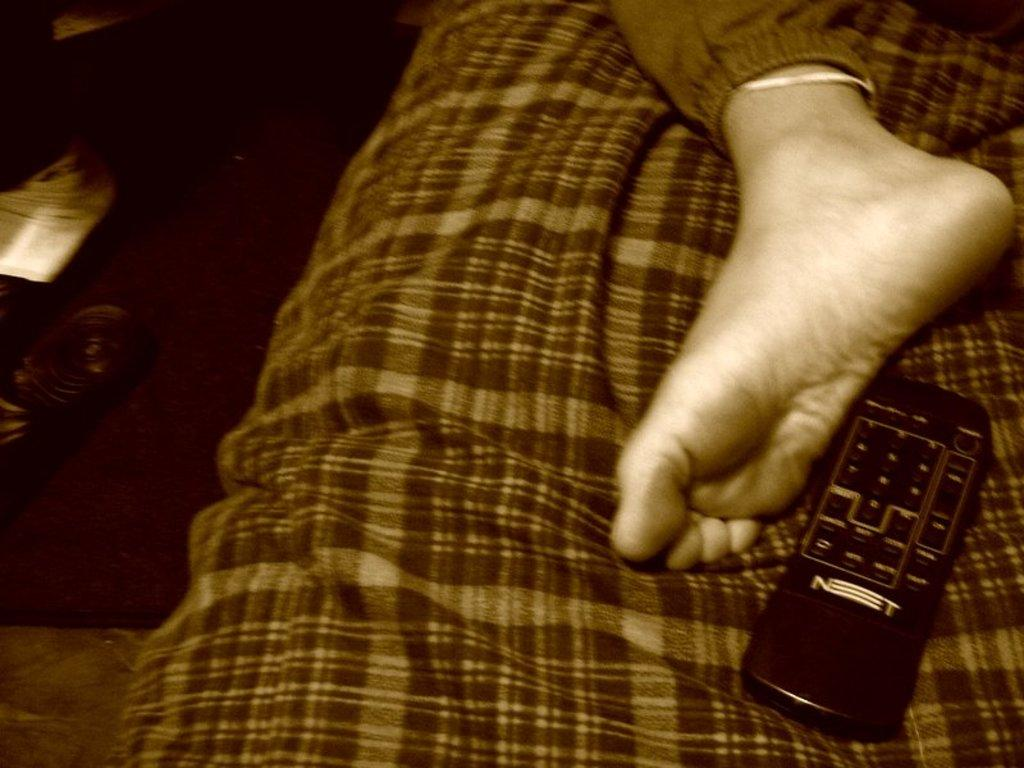<image>
Summarize the visual content of the image. a foot on a bed next to a Net remote control 